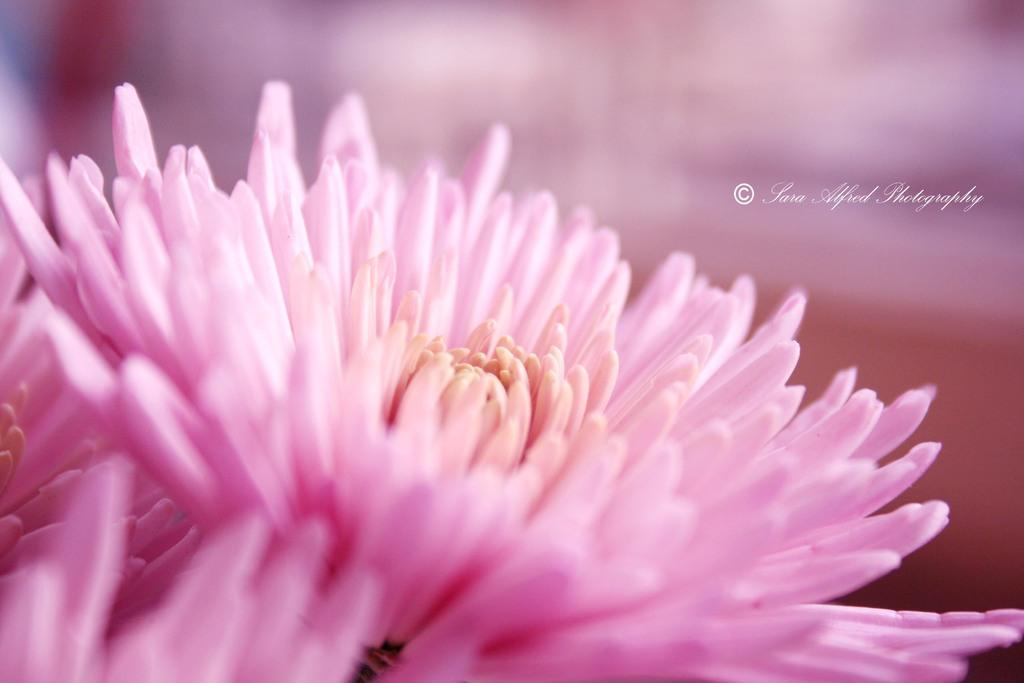What is present in the image? There is a flower in the image. Can you describe the appearance of the flower? The flower has pink color petals. Is the flower hot to touch in the image? The image does not provide information about the temperature of the flower, so it cannot be determined if it is hot to touch. 